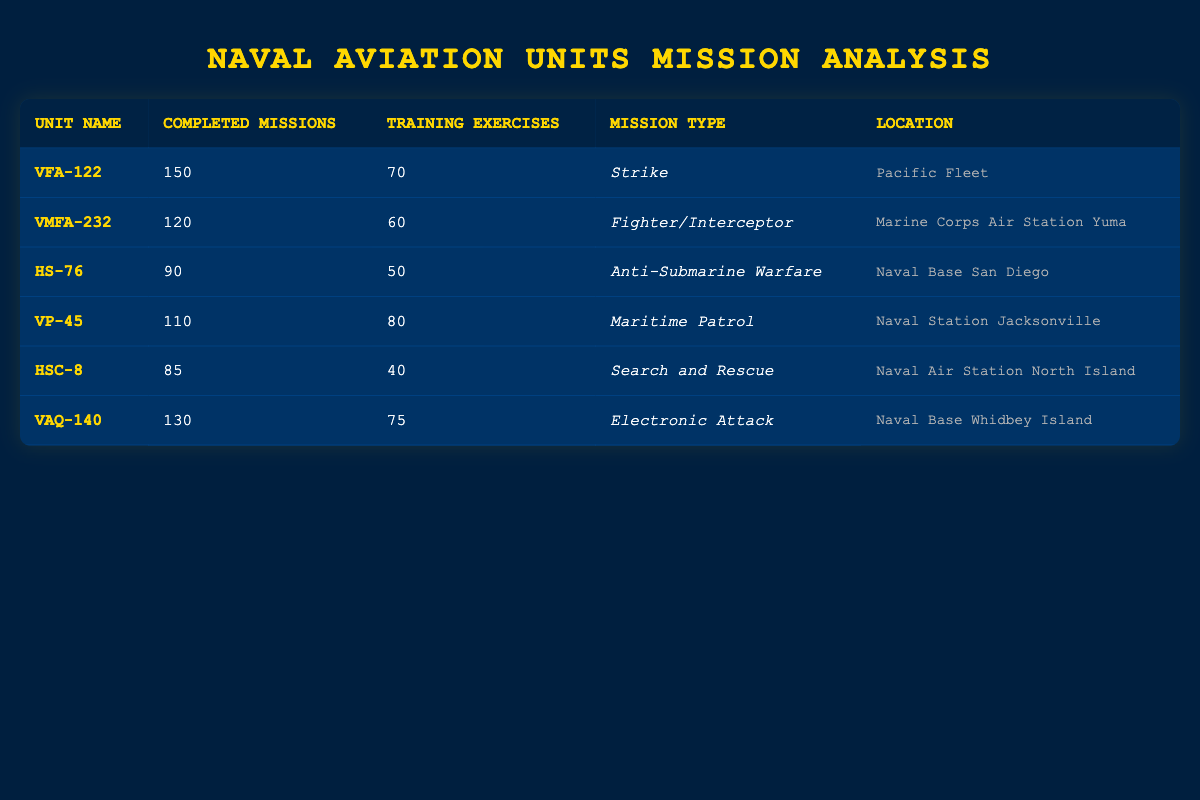What is the total number of completed missions across all units? To find the total completed missions, I add together the completed missions from each unit: 150 (VFA-122) + 120 (VMFA-232) + 90 (HS-76) + 110 (VP-45) + 85 (HSC-8) + 130 (VAQ-140) = 685.
Answer: 685 Which unit conducted the fewest training exercises? I look at the training exercises column and find the minimum value. HSC-8 with 40 training exercises has the lowest number.
Answer: HSC-8 How many more completed missions does VFA-122 have compared to VMFA-232? To find the difference in completed missions, I subtract VMFA-232's missions from VFA-122's: 150 (VFA-122) - 120 (VMFA-232) = 30.
Answer: 30 Is it true that VP-45 completed more missions than it conducted training exercises? I compare VP-45's completed missions (110) with its training exercises (80). Since 110 is greater than 80, the statement is true.
Answer: Yes What is the average number of completed missions per naval aviation unit? There are 6 units, and the total completed missions is 685. I calculate the average by dividing the total by the number of units: 685 / 6 = approximately 114.17.
Answer: 114.17 Which mission type has the highest number of completed missions? I check the completed missions for each unit and find the maximum. VFA-122 (150) has the highest number, and its mission type is Strike.
Answer: Strike What is the total number of training exercises conducted by units in the Pacific Fleet? The only unit in the Pacific Fleet is VFA-122, which conducted 70 training exercises, so the total is 70.
Answer: 70 Did all units complete more missions than they conducted training exercises? I compare each unit's completed missions to its training exercises: VFA-122, VMFA-232, VP-45, and VAQ-140 all have more completed missions. However, HSC-8 has 85 completed missions and 40 training exercises, which is also more, but HS-76 did complete more missions (90) compared to training exercises (50). Thus, the answer is true.
Answer: Yes How many units completed less than 100 missions in total? The units that completed less than 100 missions are HS-76 (90) and HSC-8 (85), totaling 2 units.
Answer: 2 What is the difference in training exercises between the unit with the most and the unit with the least? The unit with the most training exercises is VP-45 with 80, and the unit with the least is HSC-8 with 40. The difference is 80 - 40 = 40.
Answer: 40 